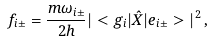Convert formula to latex. <formula><loc_0><loc_0><loc_500><loc_500>f _ { i \pm } = \frac { m \omega _ { i \pm } } { 2 h } | < g _ { i } | \hat { X } | e _ { i \pm } > | ^ { 2 } \, ,</formula> 